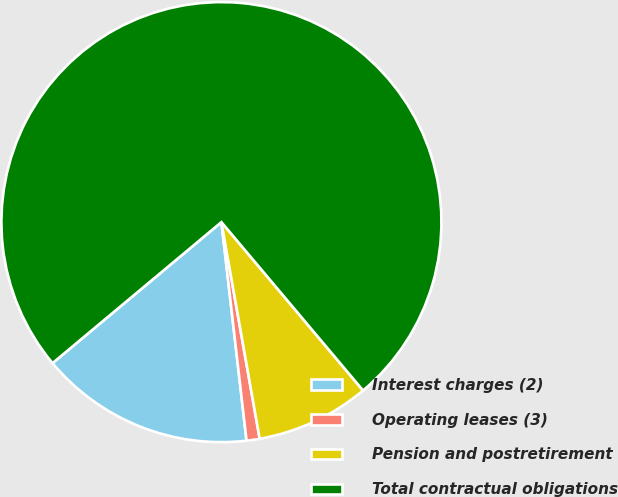Convert chart to OTSL. <chart><loc_0><loc_0><loc_500><loc_500><pie_chart><fcel>Interest charges (2)<fcel>Operating leases (3)<fcel>Pension and postretirement<fcel>Total contractual obligations<nl><fcel>15.75%<fcel>0.96%<fcel>8.35%<fcel>74.94%<nl></chart> 